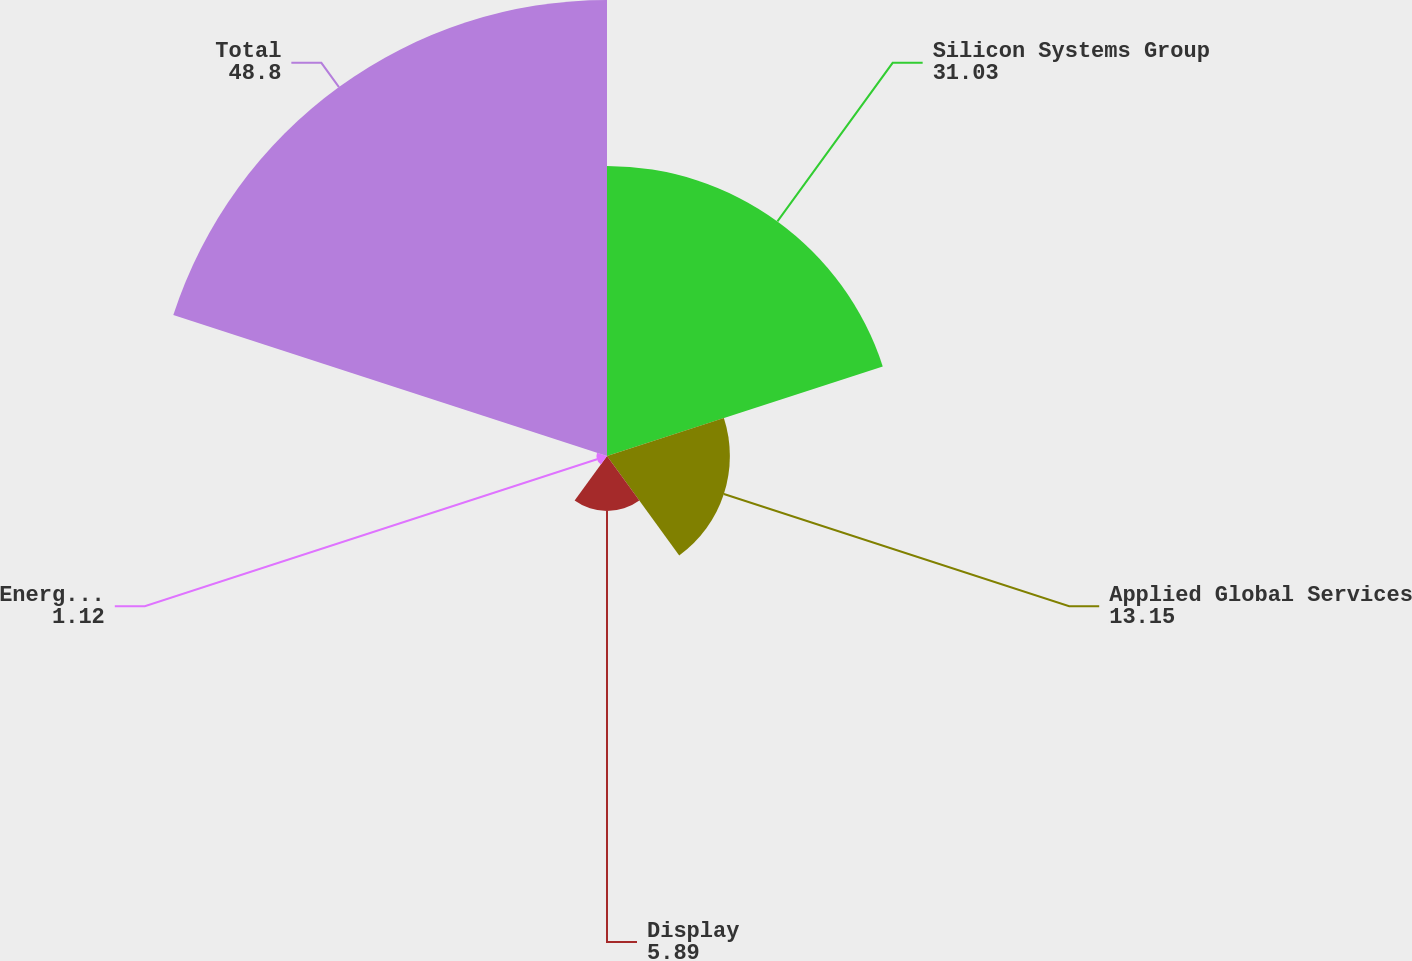Convert chart to OTSL. <chart><loc_0><loc_0><loc_500><loc_500><pie_chart><fcel>Silicon Systems Group<fcel>Applied Global Services<fcel>Display<fcel>Energy and Environmental<fcel>Total<nl><fcel>31.03%<fcel>13.15%<fcel>5.89%<fcel>1.12%<fcel>48.8%<nl></chart> 